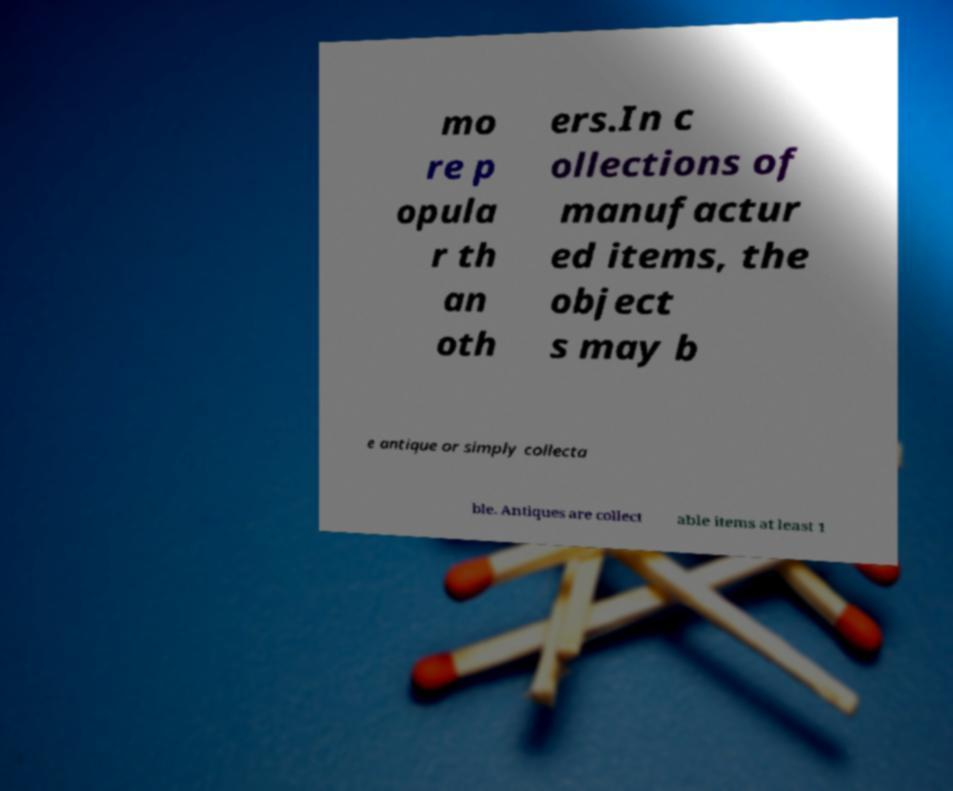Please identify and transcribe the text found in this image. mo re p opula r th an oth ers.In c ollections of manufactur ed items, the object s may b e antique or simply collecta ble. Antiques are collect able items at least 1 